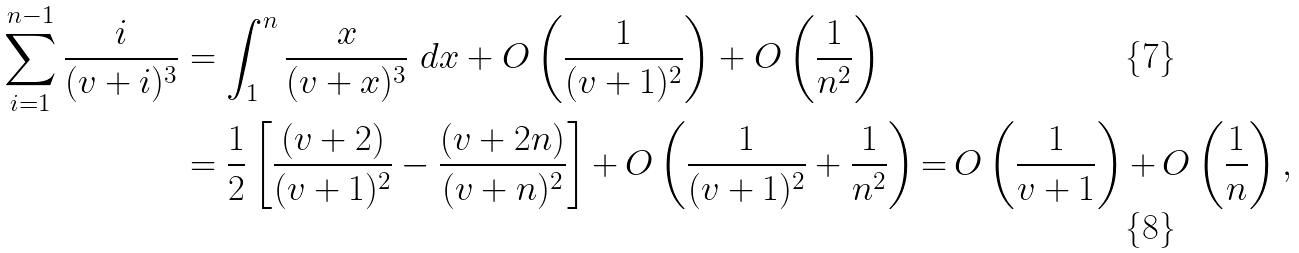<formula> <loc_0><loc_0><loc_500><loc_500>\sum _ { i = 1 } ^ { n - 1 } \frac { i } { ( v + i ) ^ { 3 } } & = \int _ { 1 } ^ { n } \frac { x } { ( v + x ) ^ { 3 } } \ d x + O \left ( \frac { 1 } { ( v + 1 ) ^ { 2 } } \right ) + O \left ( \frac { 1 } { n ^ { 2 } } \right ) \\ & = \frac { 1 } { 2 } \left [ \frac { ( v + 2 ) } { ( v + 1 ) ^ { 2 } } - \frac { ( v + 2 n ) } { ( v + n ) ^ { 2 } } \right ] { + } \, O \left ( \frac { 1 } { ( v + 1 ) ^ { 2 } } + \frac { 1 } { n ^ { 2 } } \right ) { = } \, O \left ( \frac { 1 } { v + 1 } \right ) { + } \, O \left ( \frac { 1 } { n } \right ) ,</formula> 